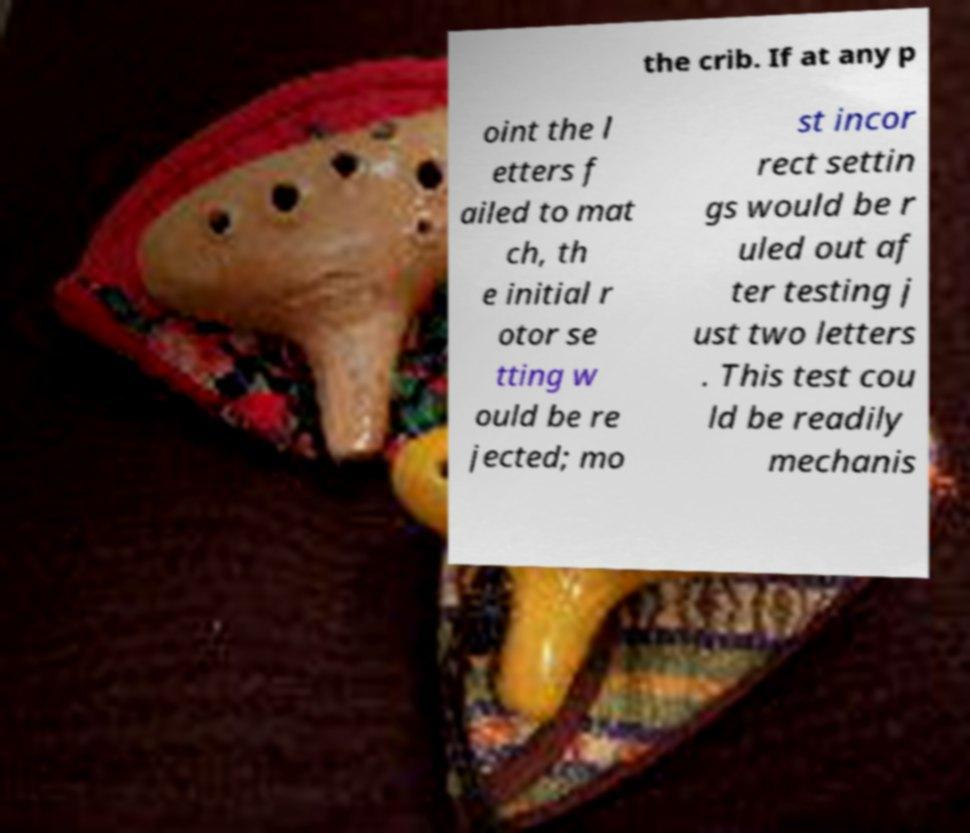Can you accurately transcribe the text from the provided image for me? the crib. If at any p oint the l etters f ailed to mat ch, th e initial r otor se tting w ould be re jected; mo st incor rect settin gs would be r uled out af ter testing j ust two letters . This test cou ld be readily mechanis 